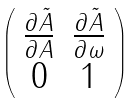<formula> <loc_0><loc_0><loc_500><loc_500>\left ( \begin{array} { c c } { { \frac { \partial \tilde { A } } { \partial A } } } & { { \frac { \partial \tilde { A } } { \partial \omega } } } \\ { 0 } & { 1 } \end{array} \right )</formula> 